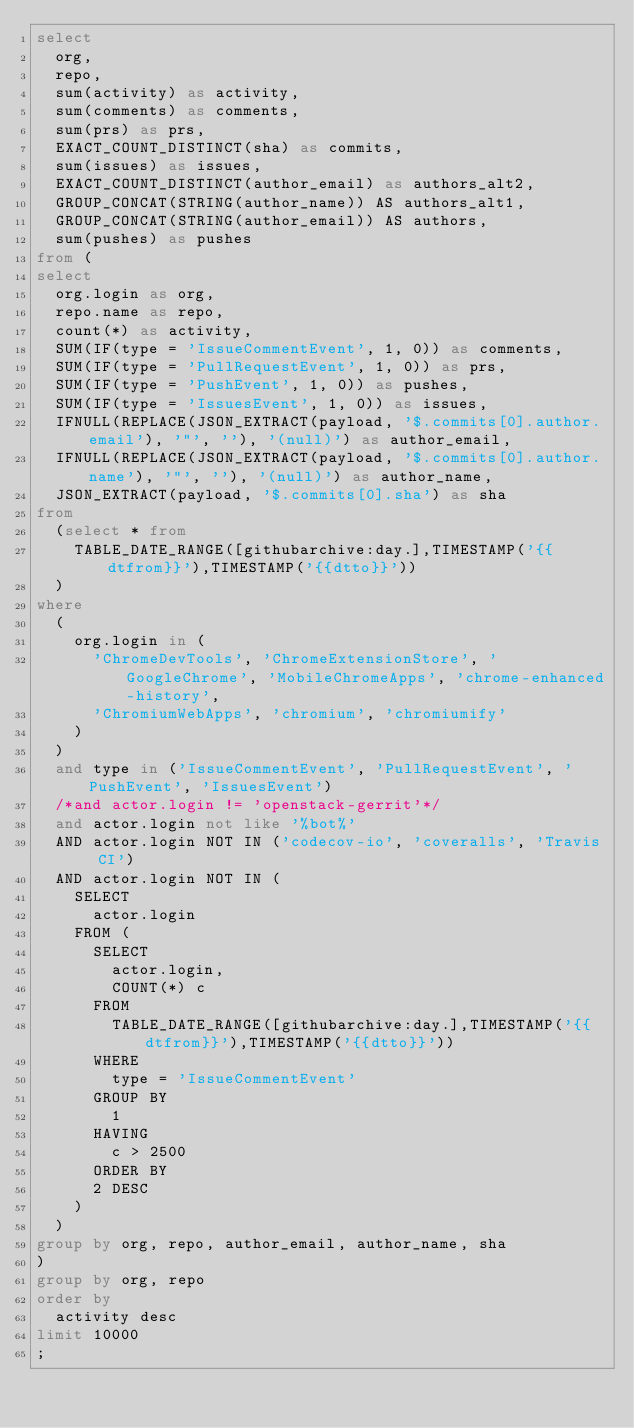Convert code to text. <code><loc_0><loc_0><loc_500><loc_500><_SQL_>select
  org,
  repo,
  sum(activity) as activity,
  sum(comments) as comments,
  sum(prs) as prs,
  EXACT_COUNT_DISTINCT(sha) as commits,
  sum(issues) as issues,
  EXACT_COUNT_DISTINCT(author_email) as authors_alt2,
  GROUP_CONCAT(STRING(author_name)) AS authors_alt1,
  GROUP_CONCAT(STRING(author_email)) AS authors,
  sum(pushes) as pushes
from (
select
  org.login as org,
  repo.name as repo,
  count(*) as activity,
  SUM(IF(type = 'IssueCommentEvent', 1, 0)) as comments,
  SUM(IF(type = 'PullRequestEvent', 1, 0)) as prs,
  SUM(IF(type = 'PushEvent', 1, 0)) as pushes,
  SUM(IF(type = 'IssuesEvent', 1, 0)) as issues,
  IFNULL(REPLACE(JSON_EXTRACT(payload, '$.commits[0].author.email'), '"', ''), '(null)') as author_email,
  IFNULL(REPLACE(JSON_EXTRACT(payload, '$.commits[0].author.name'), '"', ''), '(null)') as author_name,
  JSON_EXTRACT(payload, '$.commits[0].sha') as sha
from
  (select * from
    TABLE_DATE_RANGE([githubarchive:day.],TIMESTAMP('{{dtfrom}}'),TIMESTAMP('{{dtto}}'))
  )
where
  (
    org.login in (
      'ChromeDevTools', 'ChromeExtensionStore', 'GoogleChrome', 'MobileChromeApps', 'chrome-enhanced-history',
      'ChromiumWebApps', 'chromium', 'chromiumify'
    )
  )
  and type in ('IssueCommentEvent', 'PullRequestEvent', 'PushEvent', 'IssuesEvent')
  /*and actor.login != 'openstack-gerrit'*/
  and actor.login not like '%bot%'
  AND actor.login NOT IN ('codecov-io', 'coveralls', 'Travis CI')
  AND actor.login NOT IN (
    SELECT
      actor.login
    FROM (
      SELECT
        actor.login,
        COUNT(*) c
      FROM
        TABLE_DATE_RANGE([githubarchive:day.],TIMESTAMP('{{dtfrom}}'),TIMESTAMP('{{dtto}}'))
      WHERE
        type = 'IssueCommentEvent'
      GROUP BY
        1
      HAVING
        c > 2500
      ORDER BY
      2 DESC
    )
  )
group by org, repo, author_email, author_name, sha
)
group by org, repo
order by
  activity desc
limit 10000
;
</code> 